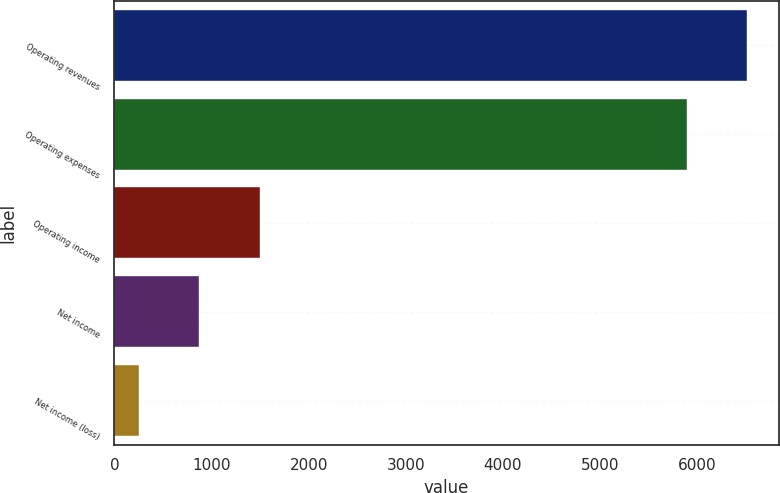<chart> <loc_0><loc_0><loc_500><loc_500><bar_chart><fcel>Operating revenues<fcel>Operating expenses<fcel>Operating income<fcel>Net income<fcel>Net income (loss)<nl><fcel>6512.6<fcel>5891<fcel>1496.2<fcel>874.6<fcel>253<nl></chart> 